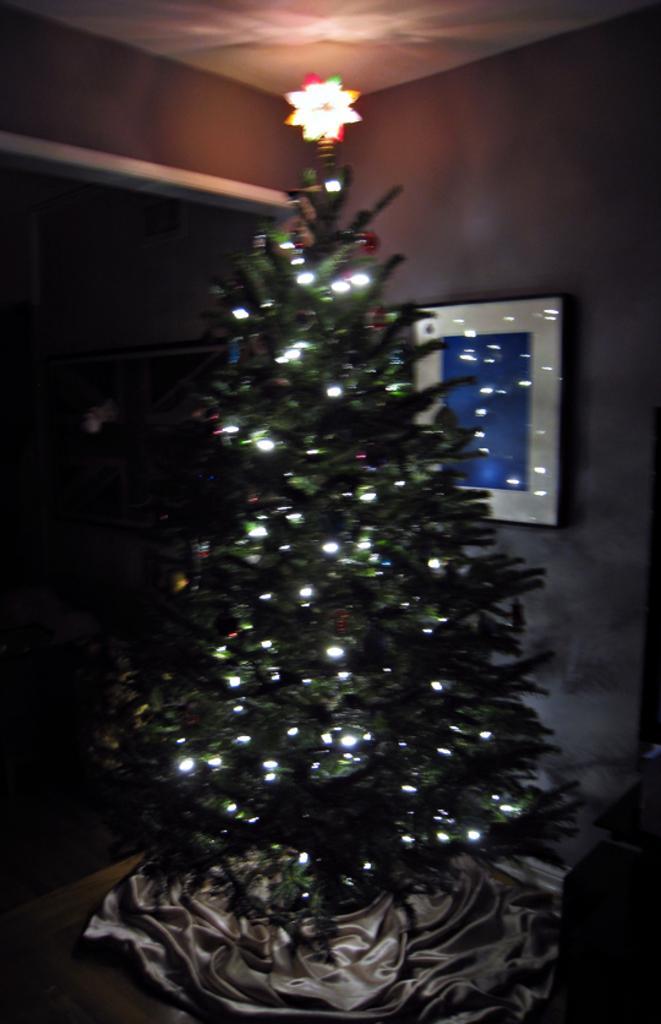Can you describe this image briefly? In this image, we can see a Christmas tree. There is a photo frame on the right side of the image. There is a ceiling at the top of the image. 